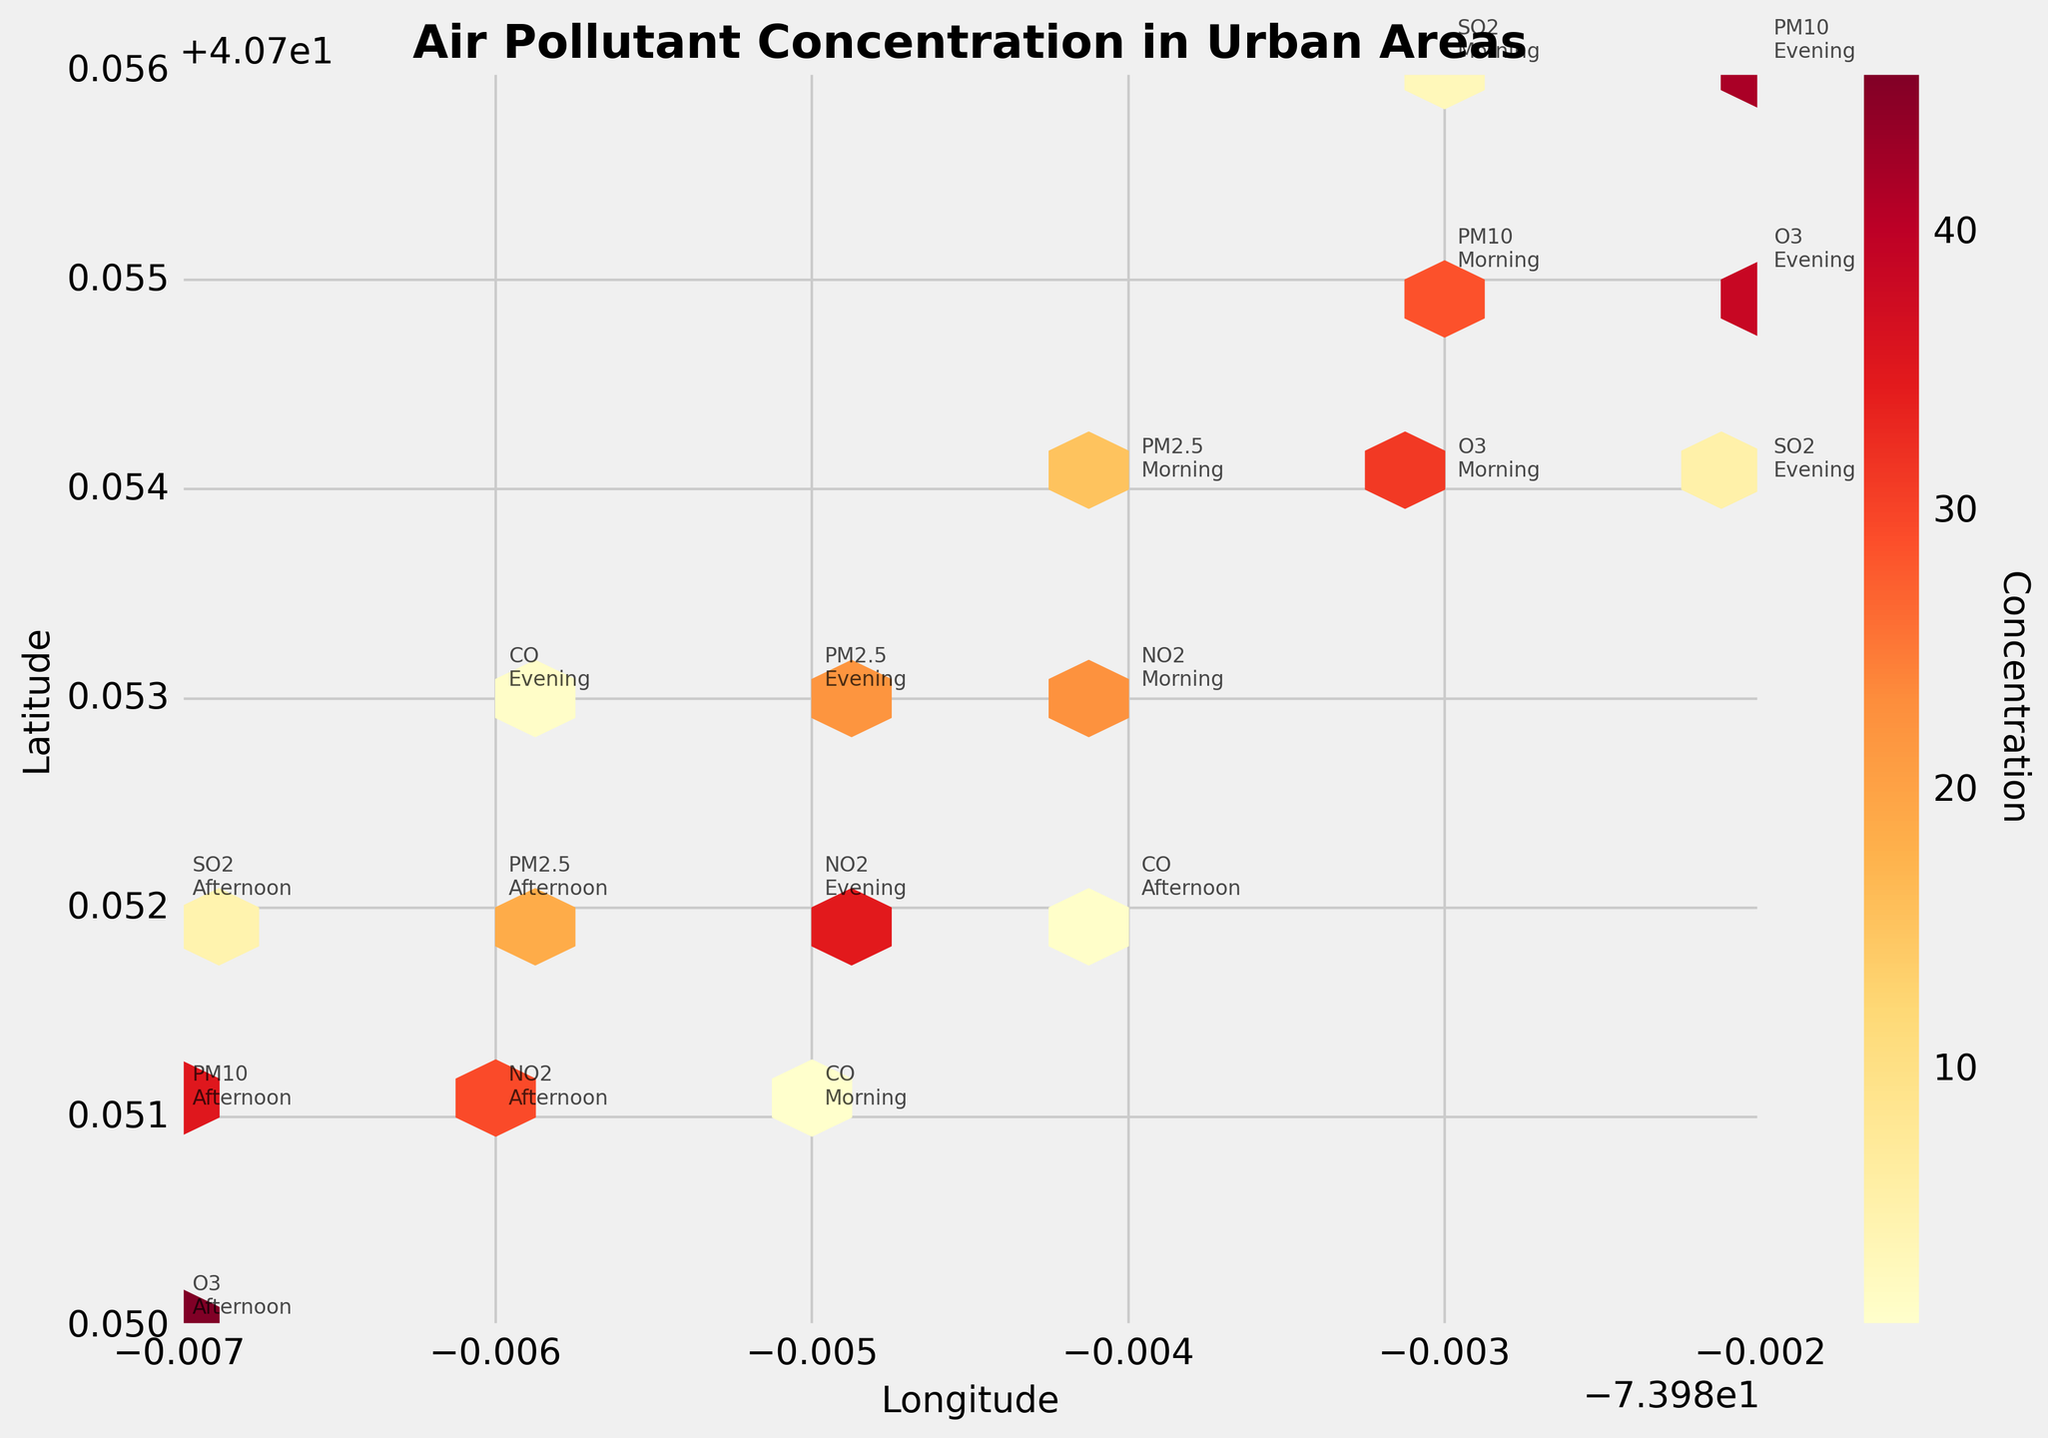What is the title of the plot? The title is typically found at the top or near the center of the plot. It is a brief descriptor summarizing the content or purpose of the chart.
Answer: "Air Pollutant Concentration in Urban Areas" Which pollutant has the highest concentration in the afternoon? To find the answer, look for annotations corresponding to afternoon readings and compare their concentrations. The highest is 45.8 for O3.
Answer: O3 How does the concentration of PM2.5 in the evening compare to the morning? Identify the PM2.5 annotations for morning and evening. In the morning, it is 15.3; in the evening, it is 22.1. Comparing the two shows the evening concentration is higher.
Answer: Evening is higher What are the axis labels of the plot? Axis labels are typically found on the horizontal and vertical axes, indicating what each axis represents. In this case, the x-axis is Longtitude and the y-axis is Latitude.
Answer: Longitude and Latitude What pollutant has the greatest concentration overall? Examine all pollutant annotations and compare their concentrations. The highest value is 45.8 for O3 in the afternoon.
Answer: O3 How frequently do concentrations exceed 30 across all pollutants? Count the number of data points with a concentration greater than 30. These are PM10 (Morning, Afternoon, Evening), NO2 (Evening), O3 (Morning, Afternoon, Evening), and SO2 (Evening). Therefore, 7 data points.
Answer: 7 Is there any pollutant with a concentration below 1? Check the annotations for any concentrations below 1. The only one is CO in the morning with 0.8.
Answer: Yes, CO in the morning What does the color intensity in the hexbin plot represent? In a hexbin plot like this, the color intensity typically correlates with the concentration. Brighter colors indicate higher concentrations.
Answer: Concentration Which type of pollutant.show higher variance in concentrations at different times of day? To find which pollutant shows higher variance, compare the range between the minimum and maximum concentrations for each pollutant. The larger the range, the higher the variance. O3 ranges from 31.2 to 45.8.
Answer: O3 What time of day shows the highest concentration for NO2? Locate the annotations for NO2 and compare them across different times of the day. In the evening, NO2 has a concentration of 34.7, which is the highest.
Answer: Evening 